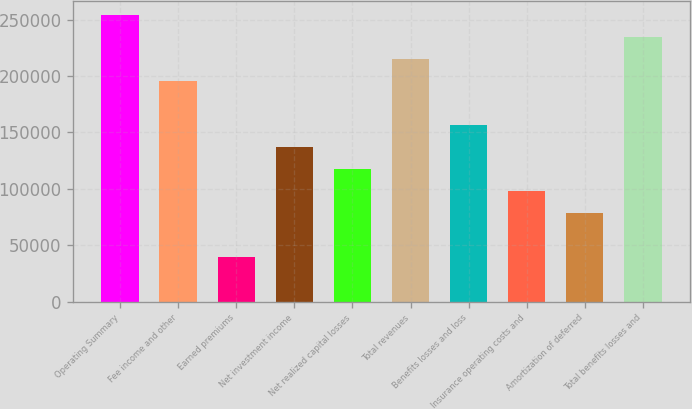Convert chart to OTSL. <chart><loc_0><loc_0><loc_500><loc_500><bar_chart><fcel>Operating Summary<fcel>Fee income and other<fcel>Earned premiums<fcel>Net investment income<fcel>Net realized capital losses<fcel>Total revenues<fcel>Benefits losses and loss<fcel>Insurance operating costs and<fcel>Amortization of deferred<fcel>Total benefits losses and<nl><fcel>254091<fcel>195464<fcel>39125.6<fcel>136837<fcel>117295<fcel>215006<fcel>156379<fcel>97752.5<fcel>78210.2<fcel>234549<nl></chart> 